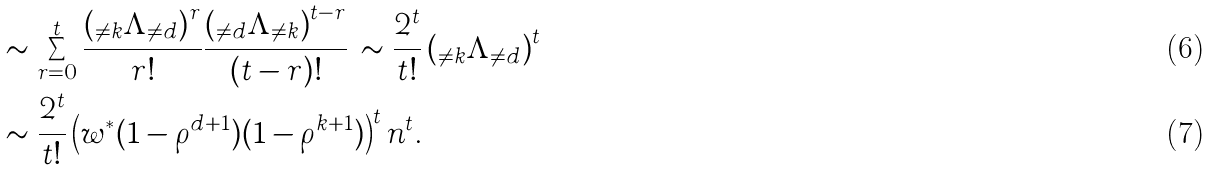<formula> <loc_0><loc_0><loc_500><loc_500>& \sim \sum _ { r = 0 } ^ { t } \frac { \left ( { _ { \neq k } } \Lambda _ { \neq d } \right ) ^ { r } } { r ! } \frac { \left ( { _ { \neq d } } \Lambda _ { \neq k } \right ) ^ { t - r } } { ( t - r ) ! } \, \sim \frac { 2 ^ { t } } { t ! } \left ( { _ { \neq k } } \Lambda _ { \neq d } \right ) ^ { t } \\ & \sim \frac { 2 ^ { t } } { t ! } \left ( w ^ { * } ( 1 - \rho ^ { d + 1 } ) ( 1 - \rho ^ { k + 1 } ) \right ) ^ { t } n ^ { t } .</formula> 